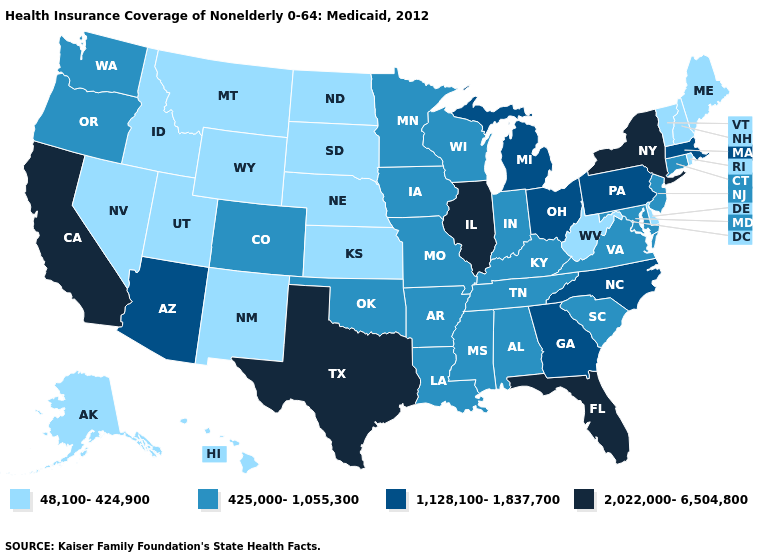Name the states that have a value in the range 2,022,000-6,504,800?
Quick response, please. California, Florida, Illinois, New York, Texas. Does Indiana have a lower value than Virginia?
Be succinct. No. Does New Jersey have the lowest value in the USA?
Answer briefly. No. Which states have the highest value in the USA?
Concise answer only. California, Florida, Illinois, New York, Texas. Name the states that have a value in the range 2,022,000-6,504,800?
Concise answer only. California, Florida, Illinois, New York, Texas. What is the value of Wyoming?
Concise answer only. 48,100-424,900. What is the highest value in states that border Ohio?
Give a very brief answer. 1,128,100-1,837,700. What is the value of Montana?
Write a very short answer. 48,100-424,900. What is the value of Maryland?
Short answer required. 425,000-1,055,300. What is the value of Louisiana?
Keep it brief. 425,000-1,055,300. Does Louisiana have the lowest value in the South?
Write a very short answer. No. Name the states that have a value in the range 425,000-1,055,300?
Quick response, please. Alabama, Arkansas, Colorado, Connecticut, Indiana, Iowa, Kentucky, Louisiana, Maryland, Minnesota, Mississippi, Missouri, New Jersey, Oklahoma, Oregon, South Carolina, Tennessee, Virginia, Washington, Wisconsin. What is the value of Montana?
Quick response, please. 48,100-424,900. Is the legend a continuous bar?
Keep it brief. No. Name the states that have a value in the range 48,100-424,900?
Give a very brief answer. Alaska, Delaware, Hawaii, Idaho, Kansas, Maine, Montana, Nebraska, Nevada, New Hampshire, New Mexico, North Dakota, Rhode Island, South Dakota, Utah, Vermont, West Virginia, Wyoming. 